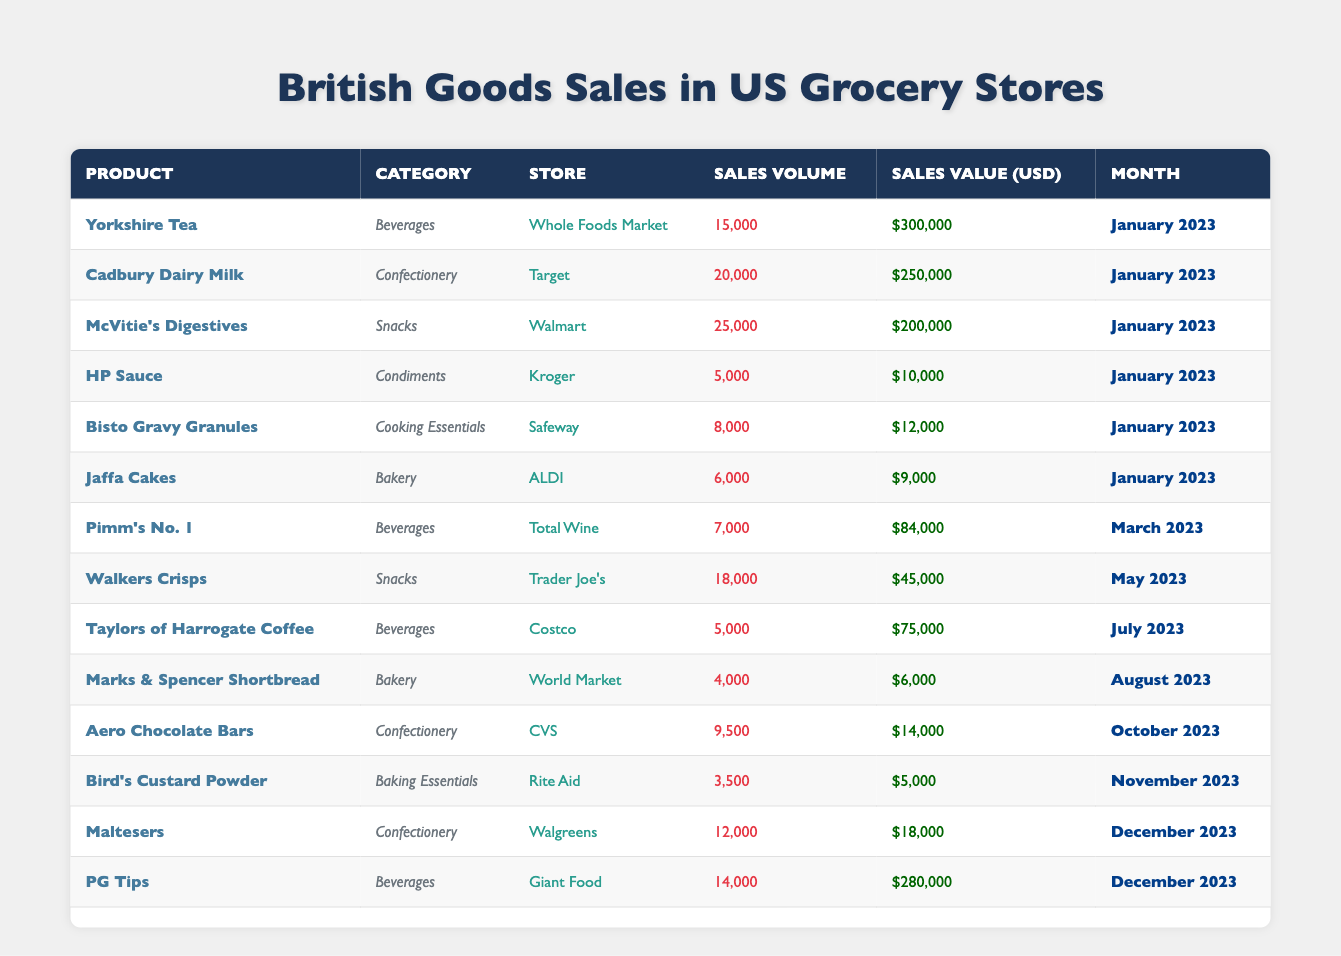What's the total sales volume of Yorkshire Tea? The sales volume of Yorkshire Tea is listed as 15,000. There are no further calculations needed since it is a single data point.
Answer: 15,000 Which product generated the highest sales value? From the table, PG Tips has a sales value of $280,000, which is higher than any other product listed.
Answer: PG Tips How many products were sold in January 2023? The data shows that there are 6 products listed in the table under January 2023.
Answer: 6 What is the average sales value of all products sold in the month of December 2023? There are two products sold in December 2023: Maltesers with a sales value of $18,000 and PG Tips with a sales value of $280,000. The total for December is $18,000 + $280,000 = $298,000. Dividing by 2 gives an average of $149,000.
Answer: $149,000 Did any products sell more than 20,000 units in January 2023? McVitie's Digestives sold 25,000 units in January 2023, which is more than 20,000.
Answer: Yes What is the total sales value of snacks sold in the data? The sales values of snacks listed are McVitie's Digestives ($200,000), Walkers Crisps ($45,000), and there are 2 other products classified as snacks. Summing these yields $200,000 + $45,000 = $245,000 for McVitie's and Walkers. Since only those two were mentioned, that's our total.
Answer: $245,000 How many brands had sales in March 2023? There is only one product, Pimm's No. 1, sold in March 2023.
Answer: 1 What is the difference in sales volume between Cadbury Dairy Milk and Jaffa Cakes? Cadbury Dairy Milk has a sales volume of 20,000 and Jaffa Cakes has a sales volume of 6,000. The difference is calculated by 20,000 - 6,000 = 14,000.
Answer: 14,000 Which store sold the most products in terms of sales volume? Based on the table, Walmart sold McVitie's Digestives with a sales volume of 25,000, which is the highest among all stores.
Answer: Walmart Was there any product that sold in both the Confectionery and Bakery categories? No, each product is distinctly categorized without overlap between Confectionery and Bakery in the provided data.
Answer: No What percentage of the total sales value for the year does Yorkshire Tea represent? Total sales value across all products is $1,580,000. Yorkshire Tea's value is $300,000. The percentage is calculated as ($300,000 / $1,580,000) * 100 ≈ 18.99%.
Answer: 18.99% 